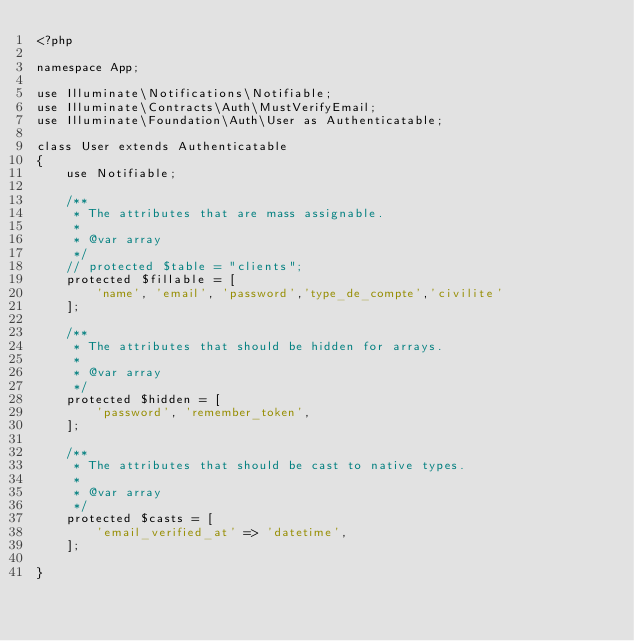Convert code to text. <code><loc_0><loc_0><loc_500><loc_500><_PHP_><?php

namespace App;

use Illuminate\Notifications\Notifiable;
use Illuminate\Contracts\Auth\MustVerifyEmail;
use Illuminate\Foundation\Auth\User as Authenticatable;

class User extends Authenticatable
{
    use Notifiable;

    /**
     * The attributes that are mass assignable.
     *
     * @var array
     */
    // protected $table = "clients";
    protected $fillable = [
        'name', 'email', 'password','type_de_compte','civilite'
    ];

    /**
     * The attributes that should be hidden for arrays.
     *
     * @var array
     */
    protected $hidden = [
        'password', 'remember_token',
    ];

    /**
     * The attributes that should be cast to native types.
     *
     * @var array
     */
    protected $casts = [
        'email_verified_at' => 'datetime',
    ];

}
</code> 